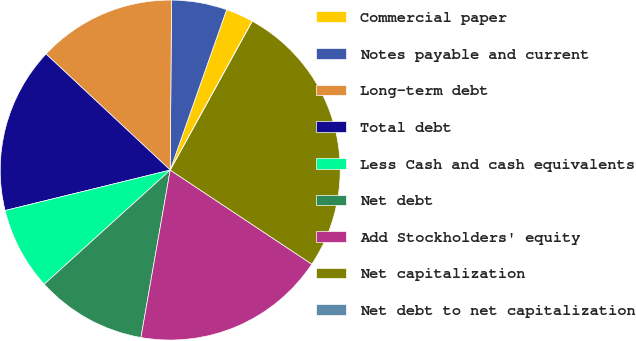<chart> <loc_0><loc_0><loc_500><loc_500><pie_chart><fcel>Commercial paper<fcel>Notes payable and current<fcel>Long-term debt<fcel>Total debt<fcel>Less Cash and cash equivalents<fcel>Net debt<fcel>Add Stockholders' equity<fcel>Net capitalization<fcel>Net debt to net capitalization<nl><fcel>2.63%<fcel>5.26%<fcel>13.16%<fcel>15.79%<fcel>7.89%<fcel>10.53%<fcel>18.42%<fcel>26.32%<fcel>0.0%<nl></chart> 